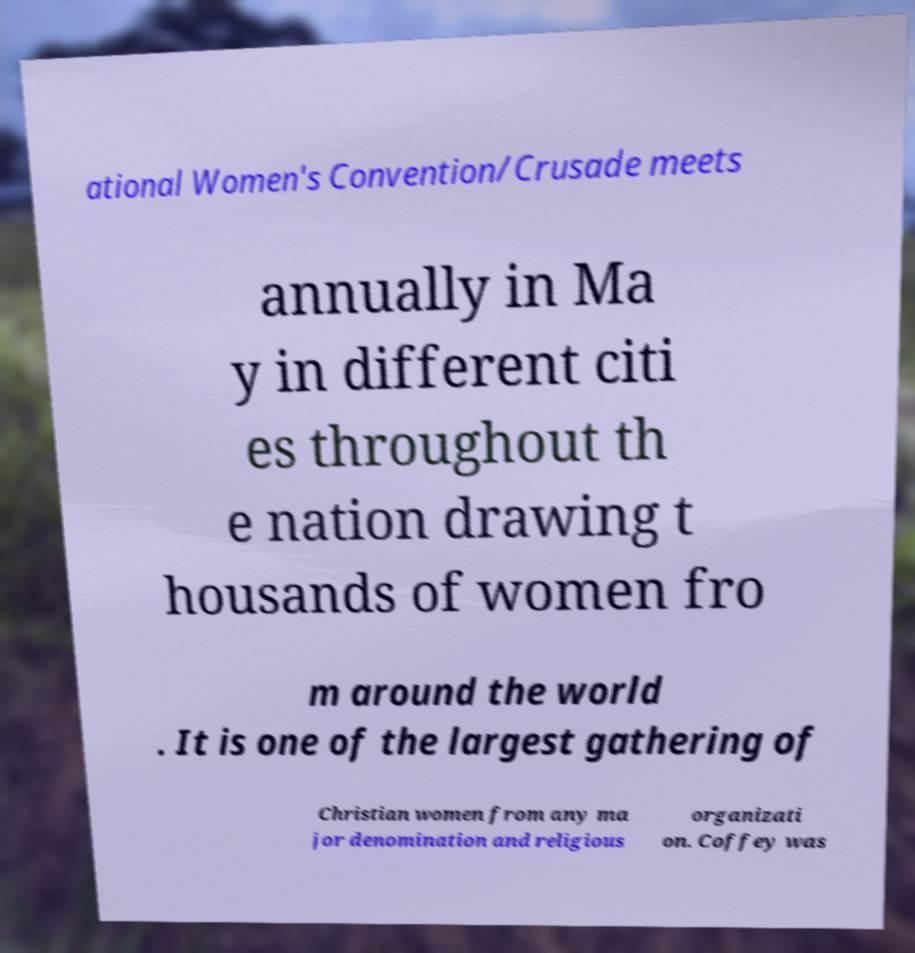What messages or text are displayed in this image? I need them in a readable, typed format. ational Women's Convention/Crusade meets annually in Ma y in different citi es throughout th e nation drawing t housands of women fro m around the world . It is one of the largest gathering of Christian women from any ma jor denomination and religious organizati on. Coffey was 